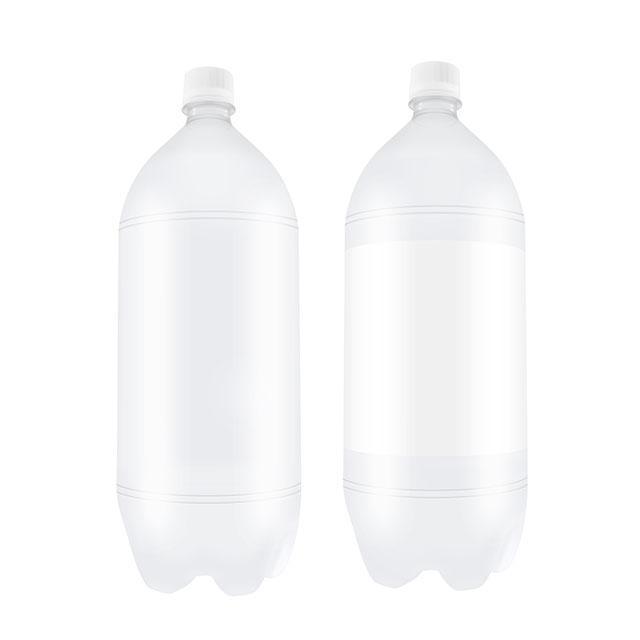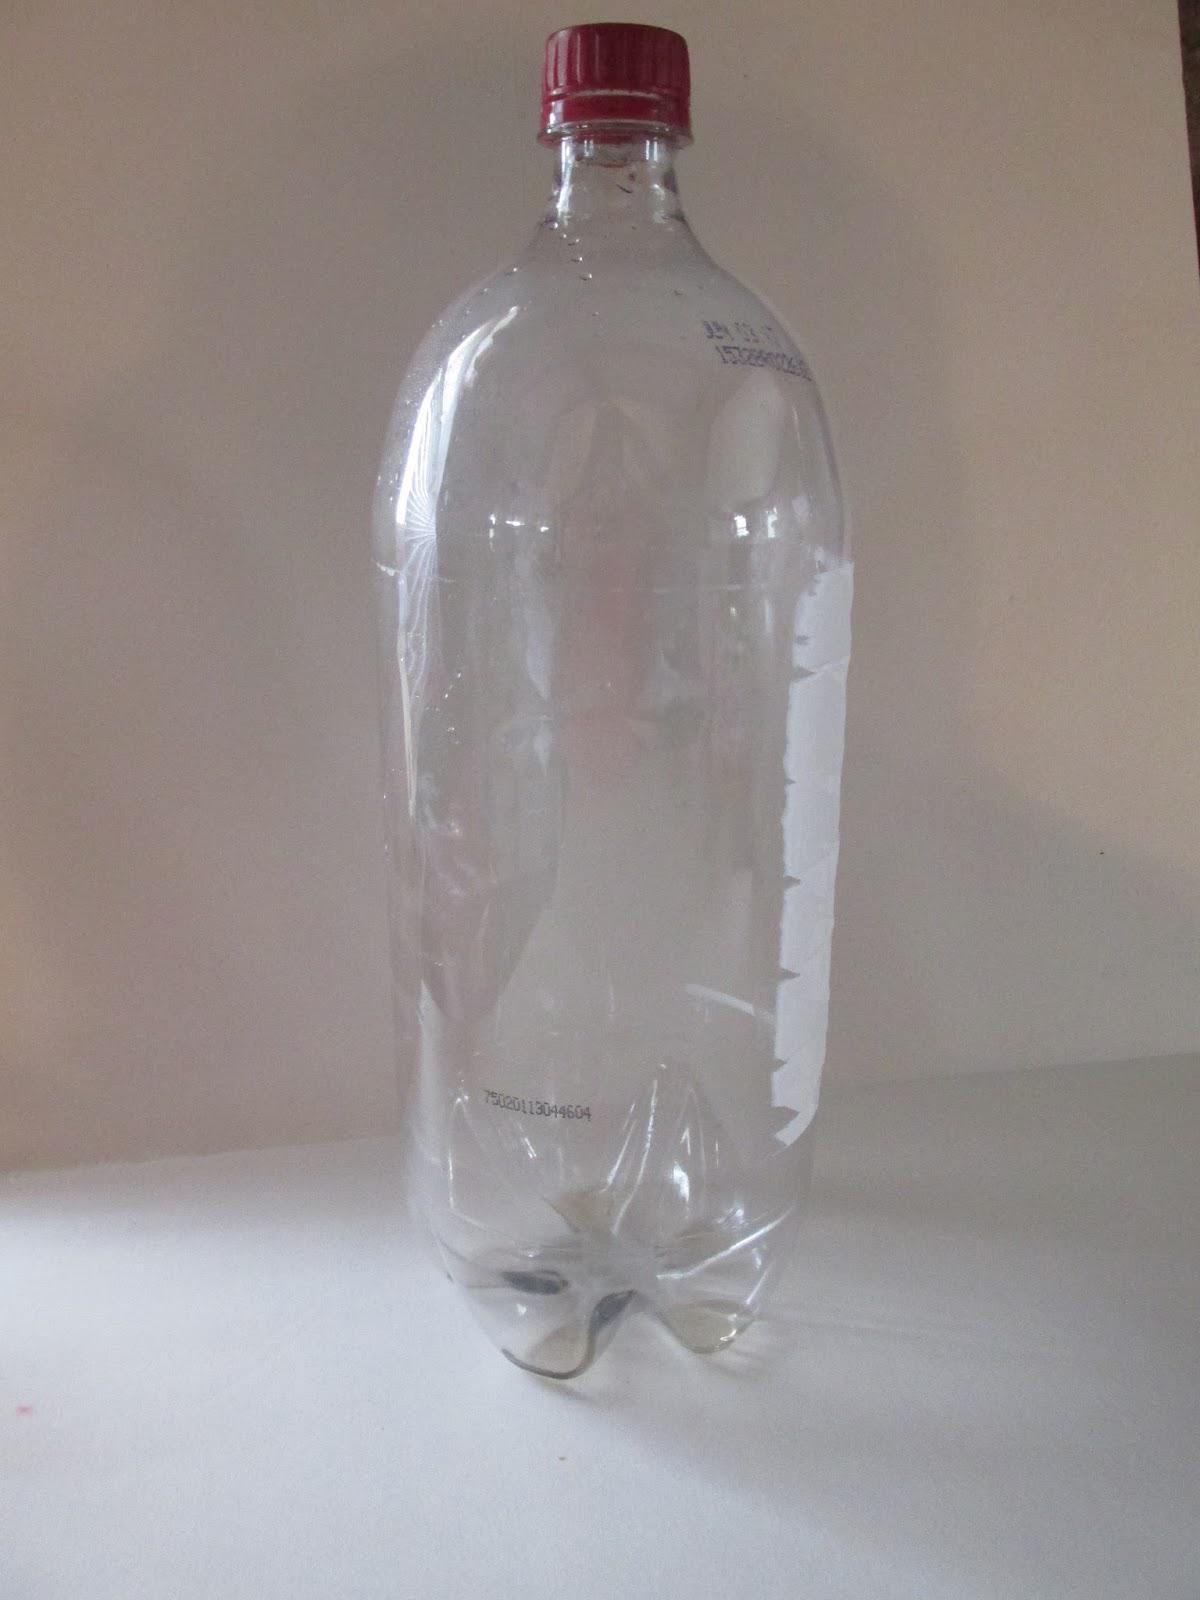The first image is the image on the left, the second image is the image on the right. Evaluate the accuracy of this statement regarding the images: "Each image shows one clear bottle, and the bottle on the left has a white lid on and is mostly cylindrical with at least one ribbed part, while the righthand bottle doesn't have its cap on.". Is it true? Answer yes or no. No. The first image is the image on the left, the second image is the image on the right. Evaluate the accuracy of this statement regarding the images: "One of the bottles comes with a lid.". Is it true? Answer yes or no. Yes. 